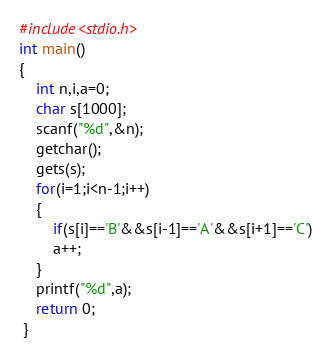Convert code to text. <code><loc_0><loc_0><loc_500><loc_500><_C_>#include<stdio.h>
int main()
{
	int n,i,a=0;
	char s[1000];
	scanf("%d",&n);
	getchar();
	gets(s);
	for(i=1;i<n-1;i++)
	{
		if(s[i]=='B'&&s[i-1]=='A'&&s[i+1]=='C')
		a++;
	}
	printf("%d",a);
	return 0;
 } </code> 